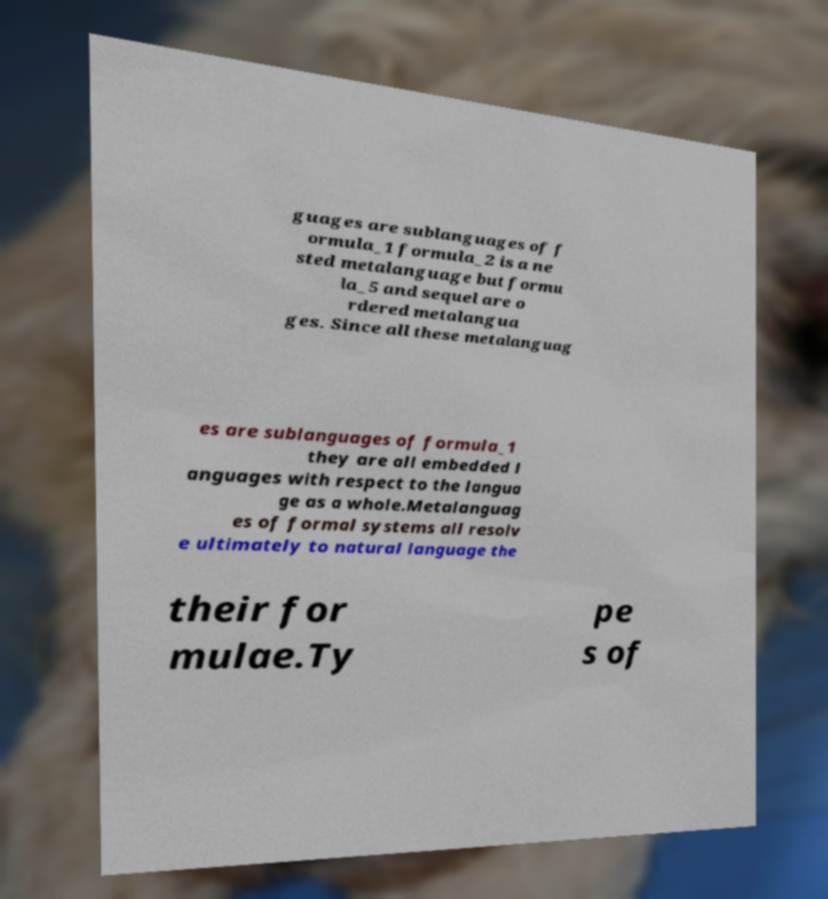There's text embedded in this image that I need extracted. Can you transcribe it verbatim? guages are sublanguages of f ormula_1 formula_2 is a ne sted metalanguage but formu la_5 and sequel are o rdered metalangua ges. Since all these metalanguag es are sublanguages of formula_1 they are all embedded l anguages with respect to the langua ge as a whole.Metalanguag es of formal systems all resolv e ultimately to natural language the their for mulae.Ty pe s of 